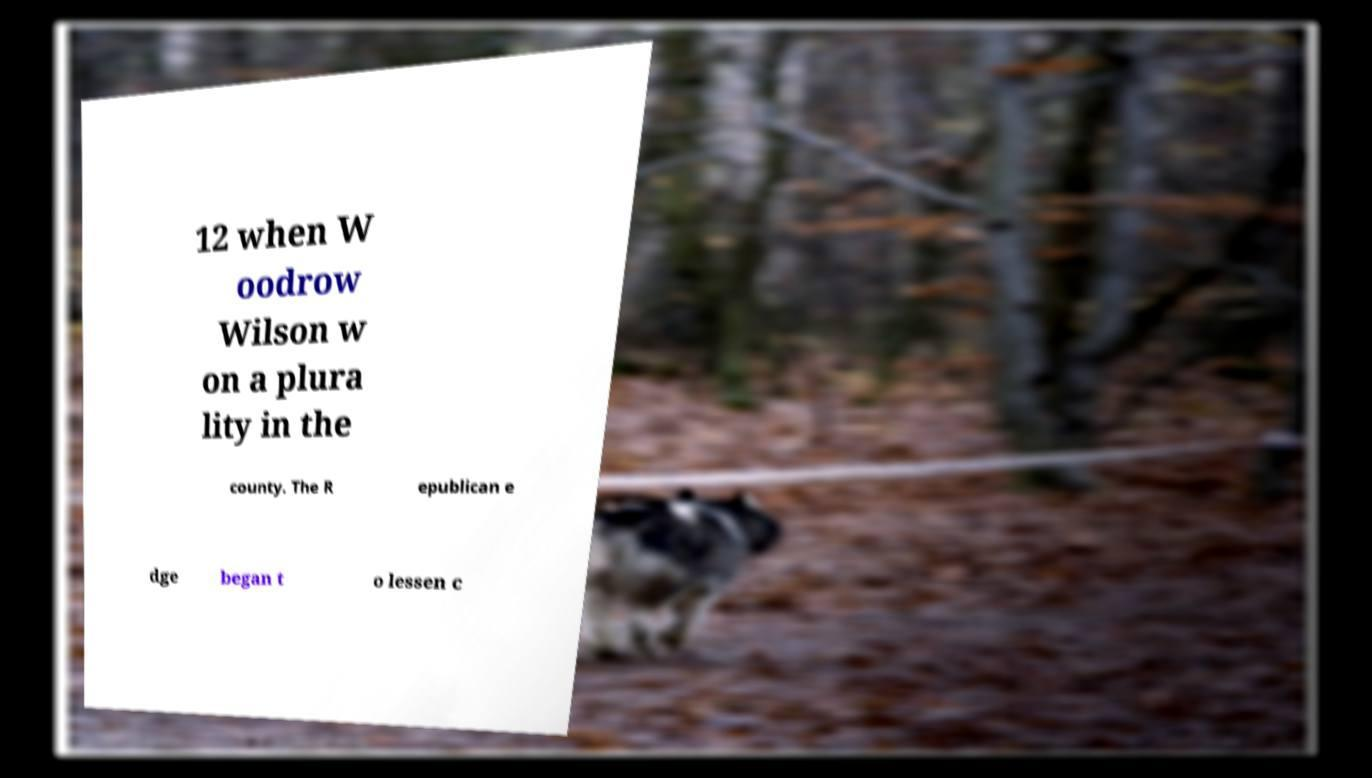Please read and relay the text visible in this image. What does it say? 12 when W oodrow Wilson w on a plura lity in the county. The R epublican e dge began t o lessen c 